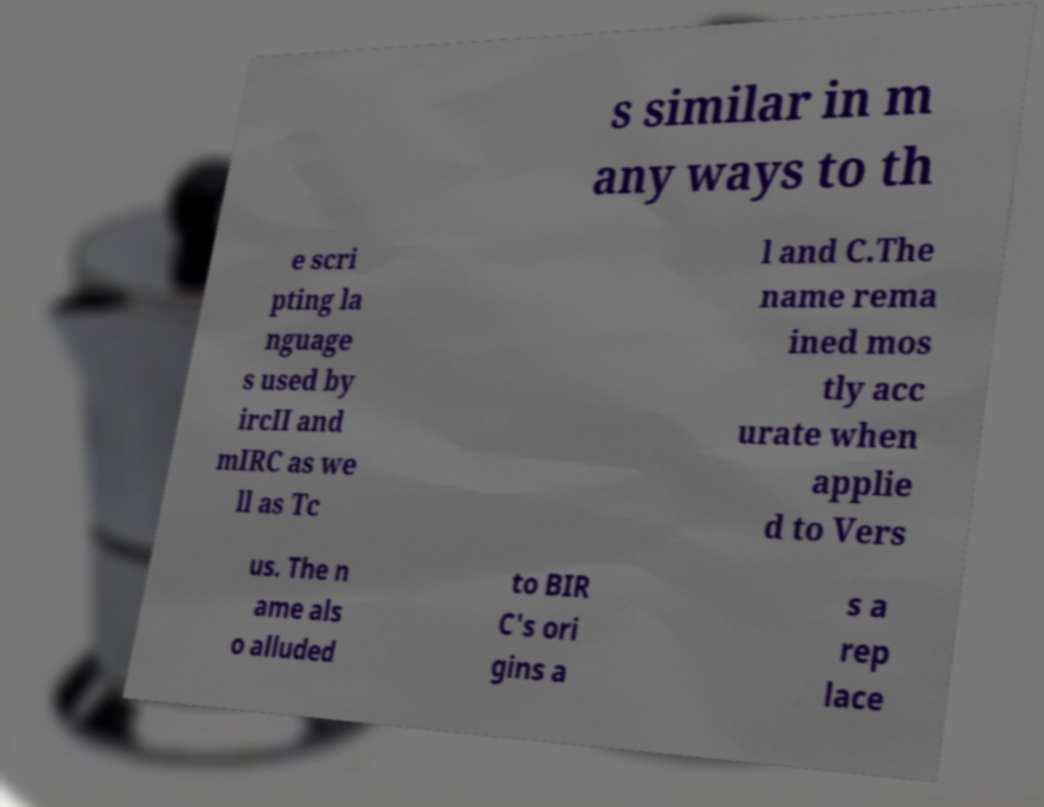Please read and relay the text visible in this image. What does it say? s similar in m any ways to th e scri pting la nguage s used by ircII and mIRC as we ll as Tc l and C.The name rema ined mos tly acc urate when applie d to Vers us. The n ame als o alluded to BIR C's ori gins a s a rep lace 